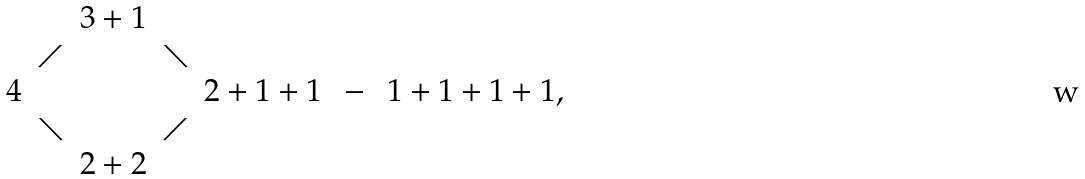Convert formula to latex. <formula><loc_0><loc_0><loc_500><loc_500>\begin{array} { c c c c c c c } & & 3 + 1 & & & & \\ & \diagup & & \diagdown & & & \\ 4 & & & & 2 + 1 + 1 & \, - \, & 1 + 1 + 1 + 1 , \\ & \diagdown & & \diagup & & & \\ & & 2 + 2 & & & & \end{array}</formula> 